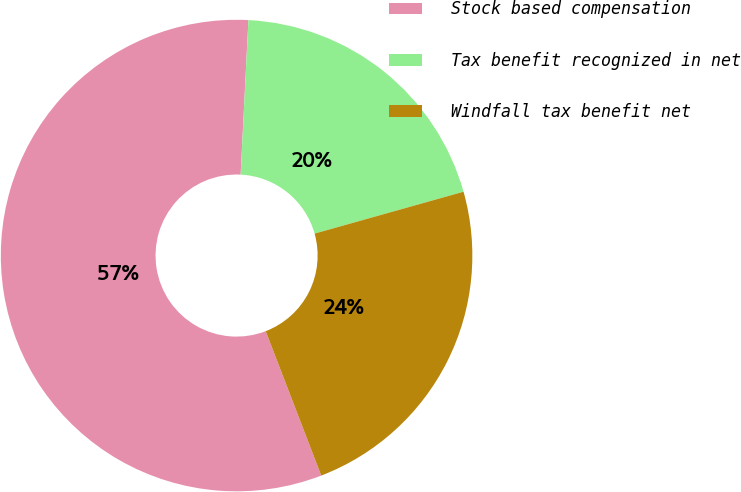Convert chart to OTSL. <chart><loc_0><loc_0><loc_500><loc_500><pie_chart><fcel>Stock based compensation<fcel>Tax benefit recognized in net<fcel>Windfall tax benefit net<nl><fcel>56.65%<fcel>19.84%<fcel>23.52%<nl></chart> 